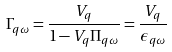Convert formula to latex. <formula><loc_0><loc_0><loc_500><loc_500>\Gamma _ { q \omega } = \frac { V _ { q } } { 1 - V _ { q } \Pi _ { q \omega } } = \frac { V _ { q } } { \epsilon _ { q \omega } }</formula> 